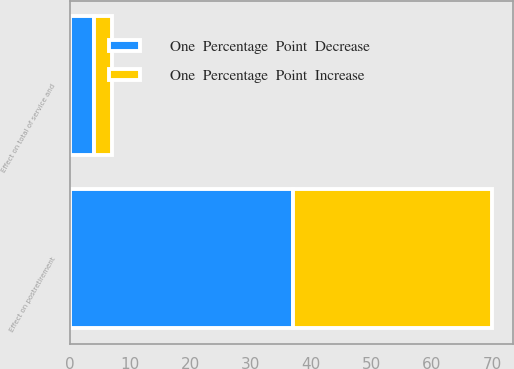<chart> <loc_0><loc_0><loc_500><loc_500><stacked_bar_chart><ecel><fcel>Effect on total of service and<fcel>Effect on postretirement<nl><fcel>One  Percentage  Point  Decrease<fcel>4<fcel>37<nl><fcel>One  Percentage  Point  Increase<fcel>3<fcel>33<nl></chart> 